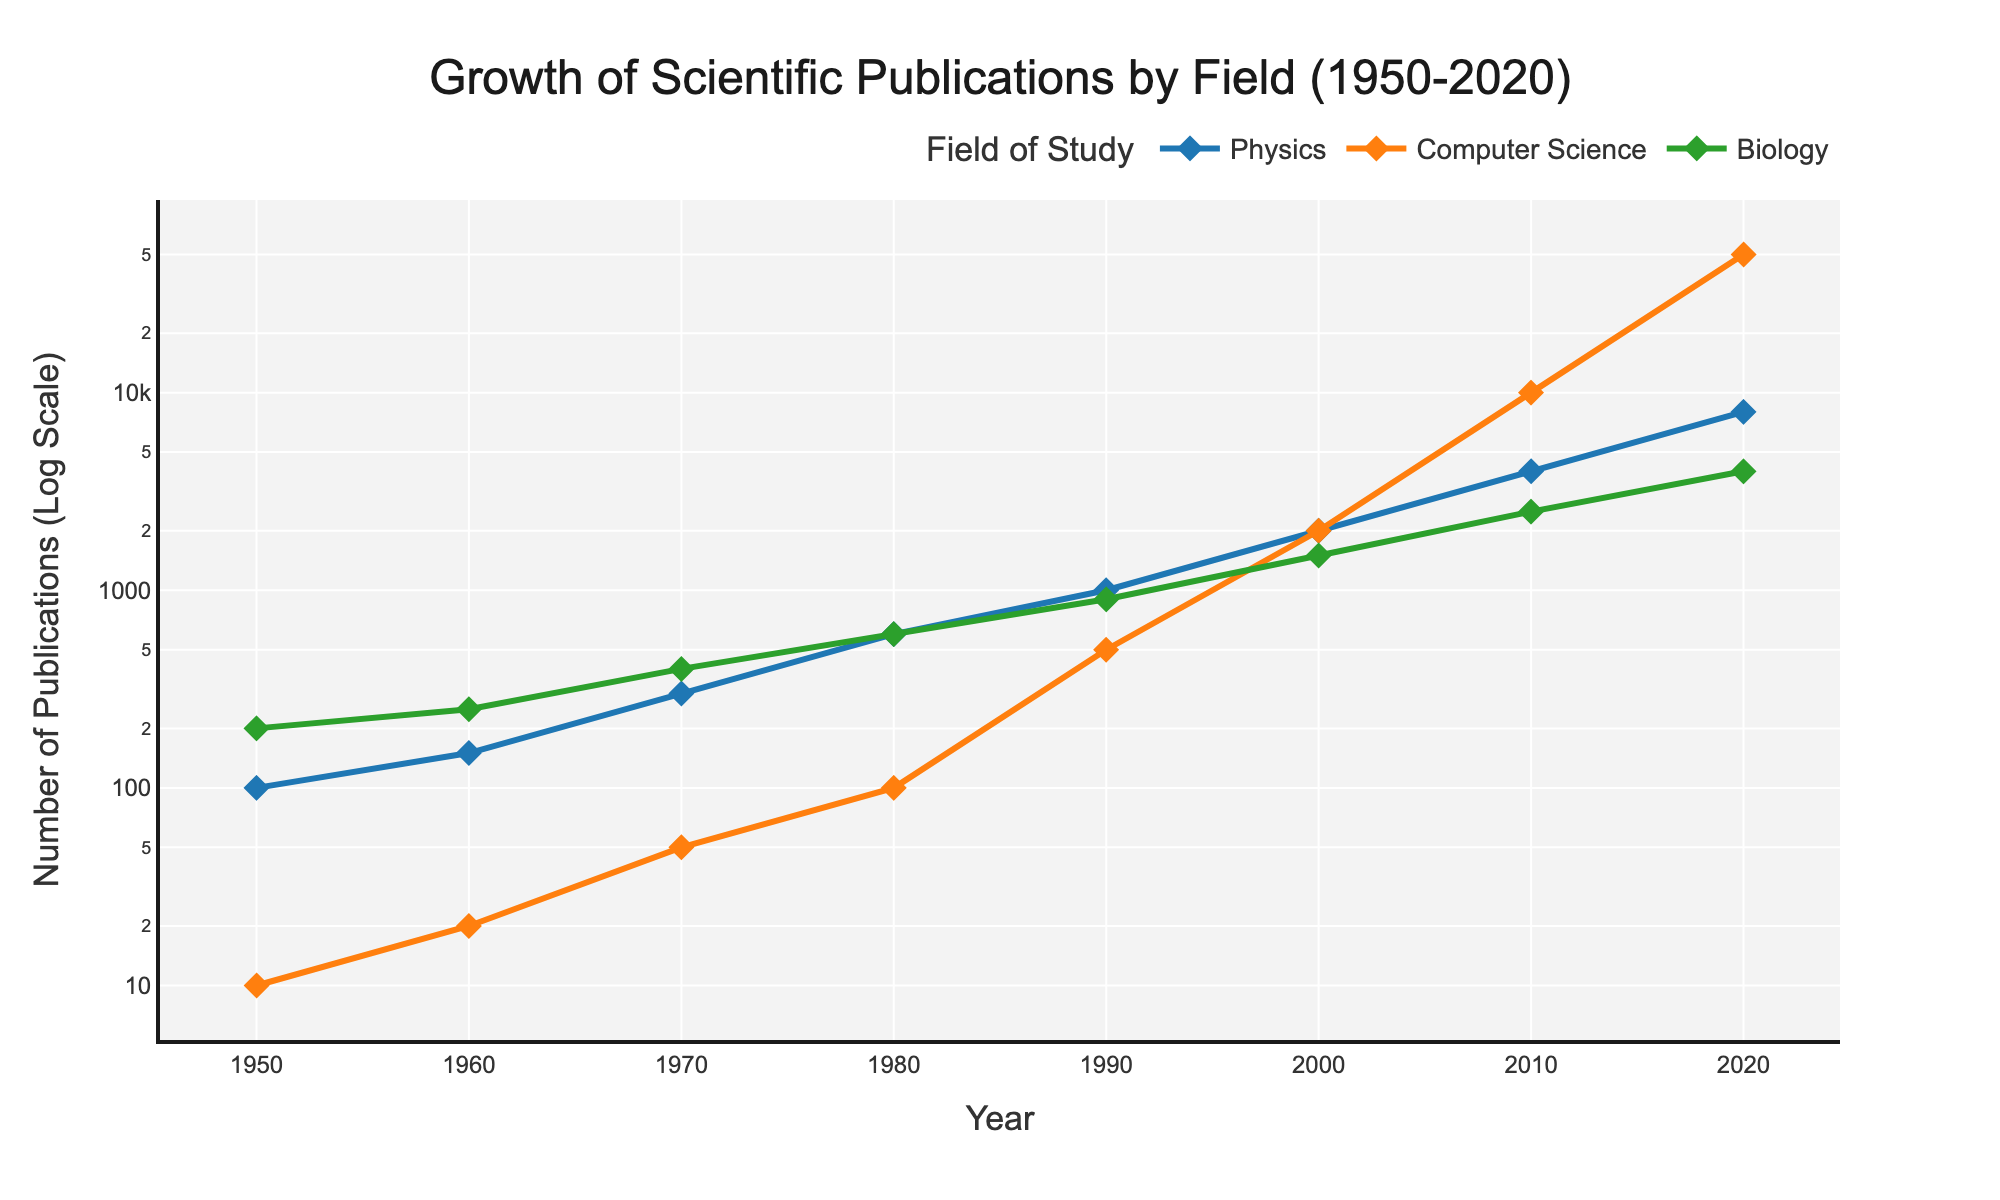What is the title of the figure? The title of the figure is displayed at the top of the plot. It reads "Growth of Scientific Publications by Field (1950-2020)".
Answer: Growth of Scientific Publications by Field (1950-2020) What is the y-axis title? The y-axis title is displayed next to the vertical axis. It reads "Number of Publications (Log Scale)".
Answer: Number of Publications (Log Scale) Which field has the highest number of publications in 2020? By observing the data points in 2020, Computer Science has the highest number of publications among the three fields.
Answer: Computer Science In which year did Computer Science publications first exceed 1000? Looking at the line plot for Computer Science, we see that the number of publications exceeds 1000 in the year 2000.
Answer: 2000 Which field experienced the most noticeable growth between 1980 and 2020? By comparing the slopes of the lines for each field between 1980 and 2020, Computer Science shows the steepest slope, indicating the most rapid growth.
Answer: Computer Science How many publications were there in Biology in 1990? Focusing on the Biology line for the year 1990, the data point indicates 900 publications.
Answer: 900 Compare the number of publications in Physics and Biology in 1980. Which field had more publications? By observing the data points for 1980, Physics had 600 publications and Biology also had 600 publications. Therefore, they had an equal number of publications.
Answer: Equal What is the average annual growth rate of publications in Physics from 2000 to 2020? To find the average annual growth rate, we take the initial and final number of publications in Physics (2000 in 2000 and 8000 in 2020). The growth rate is \(\frac{8000 - 2000}{20} = 300\) publications per year.
Answer: 300 publications per year At what year did Biology publications reach 4000? By observing the Biology line, the number of publications in Biology reaches 4000 in the year 2020.
Answer: 2020 Plot the trend of all three fields between 1950 and 2020. Which field has the most consistent growth? By comparing the smoothness of the growth lines of all three fields from 1950 to 2020, Physics shows the most consistent growth pattern without drastic changes.
Answer: Physics 